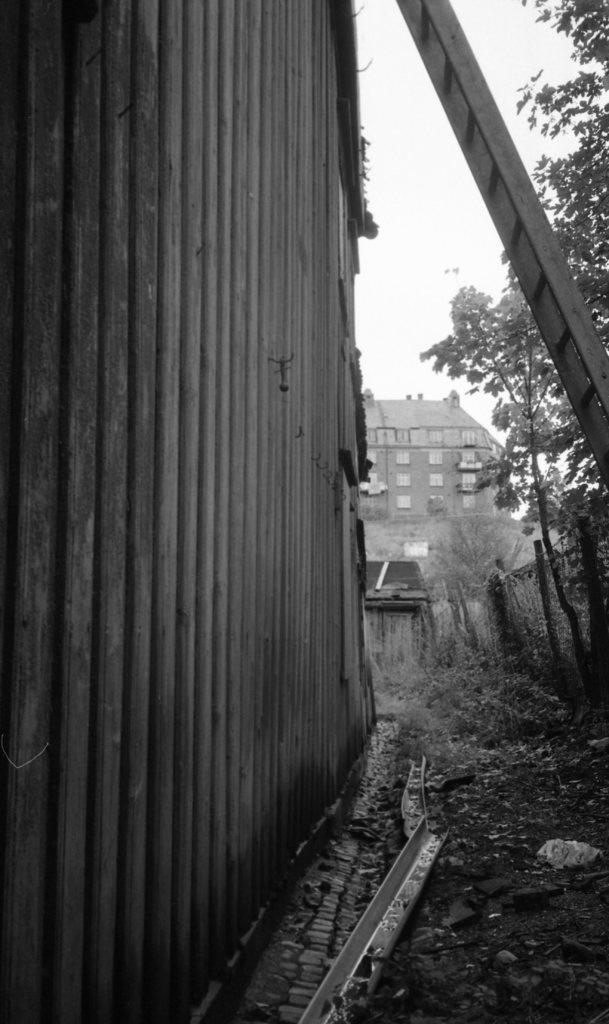What is the color scheme of the image? The image is black and white. What type of structure can be seen in the image? There is a wall in the image. What natural elements are present in the image? There are trees in the image. What object is used for climbing in the image? There is a ladder in the image. What type of building is visible in the image? There is a building with windows in the image. What type of current can be seen flowing through the building in the image? There is no current visible in the image, as it is a black and white photograph. How many cubs are visible in the image? There are no cubs present in the image. 